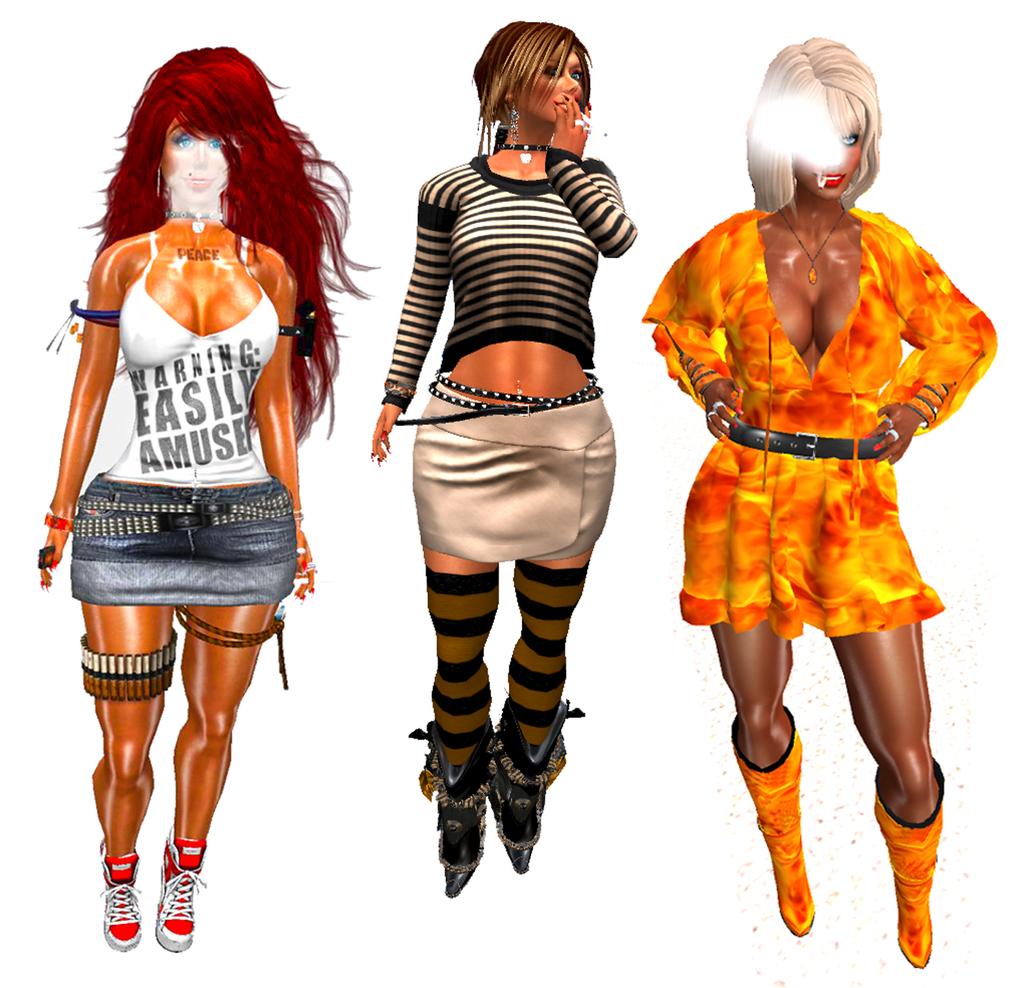What does the shirt on the left warn about?
Provide a short and direct response. Easily amused. 